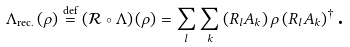<formula> <loc_0><loc_0><loc_500><loc_500>\Lambda _ { \text {rec.} } \left ( \rho \right ) \overset { \text {def} } { = } \left ( \mathcal { R } \circ \Lambda \right ) \left ( \rho \right ) = \sum _ { l } \sum _ { k } \left ( R _ { l } A _ { k } \right ) \rho \left ( R _ { l } A _ { k } \right ) ^ { \dagger } \text {.}</formula> 